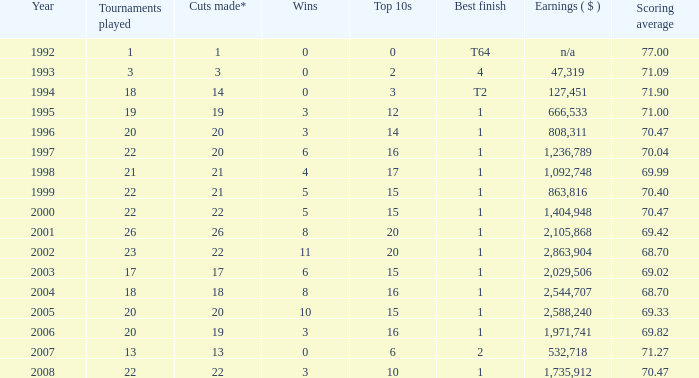What is the greatest number of wins in a year before 2000, with a top finish of 4 and participating in fewer than 3 tournaments? None. 